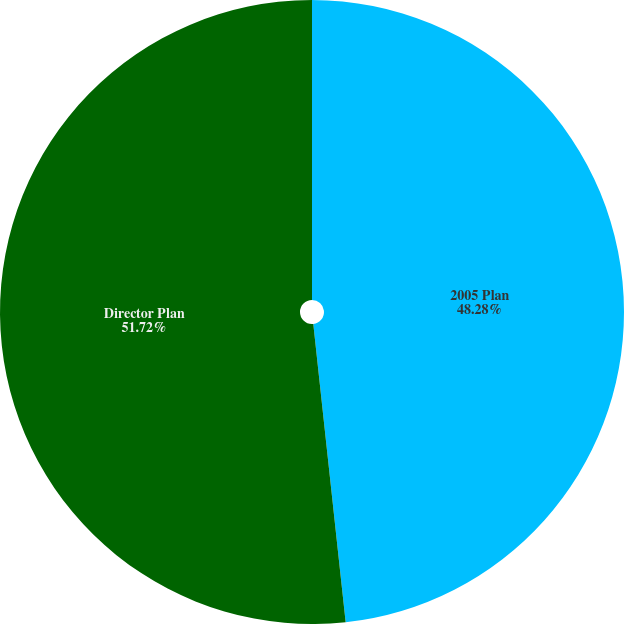Convert chart. <chart><loc_0><loc_0><loc_500><loc_500><pie_chart><fcel>2005 Plan<fcel>Director Plan<nl><fcel>48.28%<fcel>51.72%<nl></chart> 